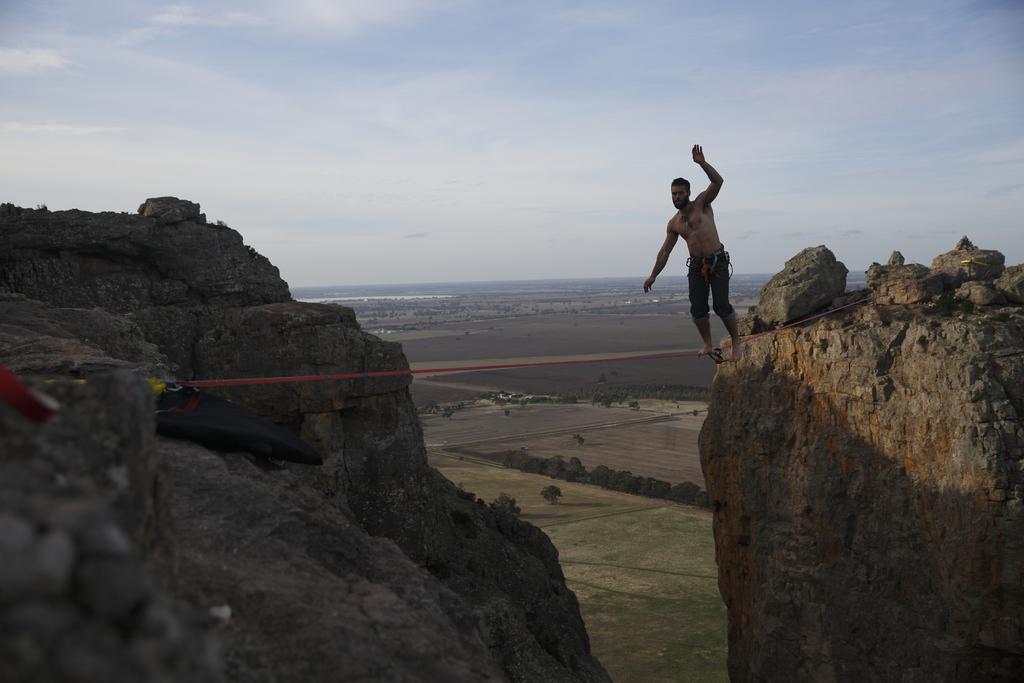In one or two sentences, can you explain what this image depicts? In this picture there is a man walking on a rope and we can see hills and objects. In the background of the image we can see trees, grass and sky. 